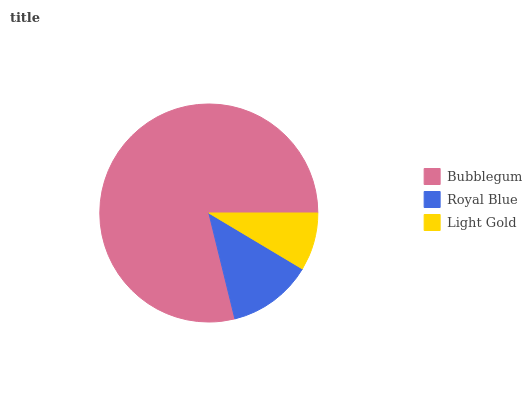Is Light Gold the minimum?
Answer yes or no. Yes. Is Bubblegum the maximum?
Answer yes or no. Yes. Is Royal Blue the minimum?
Answer yes or no. No. Is Royal Blue the maximum?
Answer yes or no. No. Is Bubblegum greater than Royal Blue?
Answer yes or no. Yes. Is Royal Blue less than Bubblegum?
Answer yes or no. Yes. Is Royal Blue greater than Bubblegum?
Answer yes or no. No. Is Bubblegum less than Royal Blue?
Answer yes or no. No. Is Royal Blue the high median?
Answer yes or no. Yes. Is Royal Blue the low median?
Answer yes or no. Yes. Is Light Gold the high median?
Answer yes or no. No. Is Light Gold the low median?
Answer yes or no. No. 